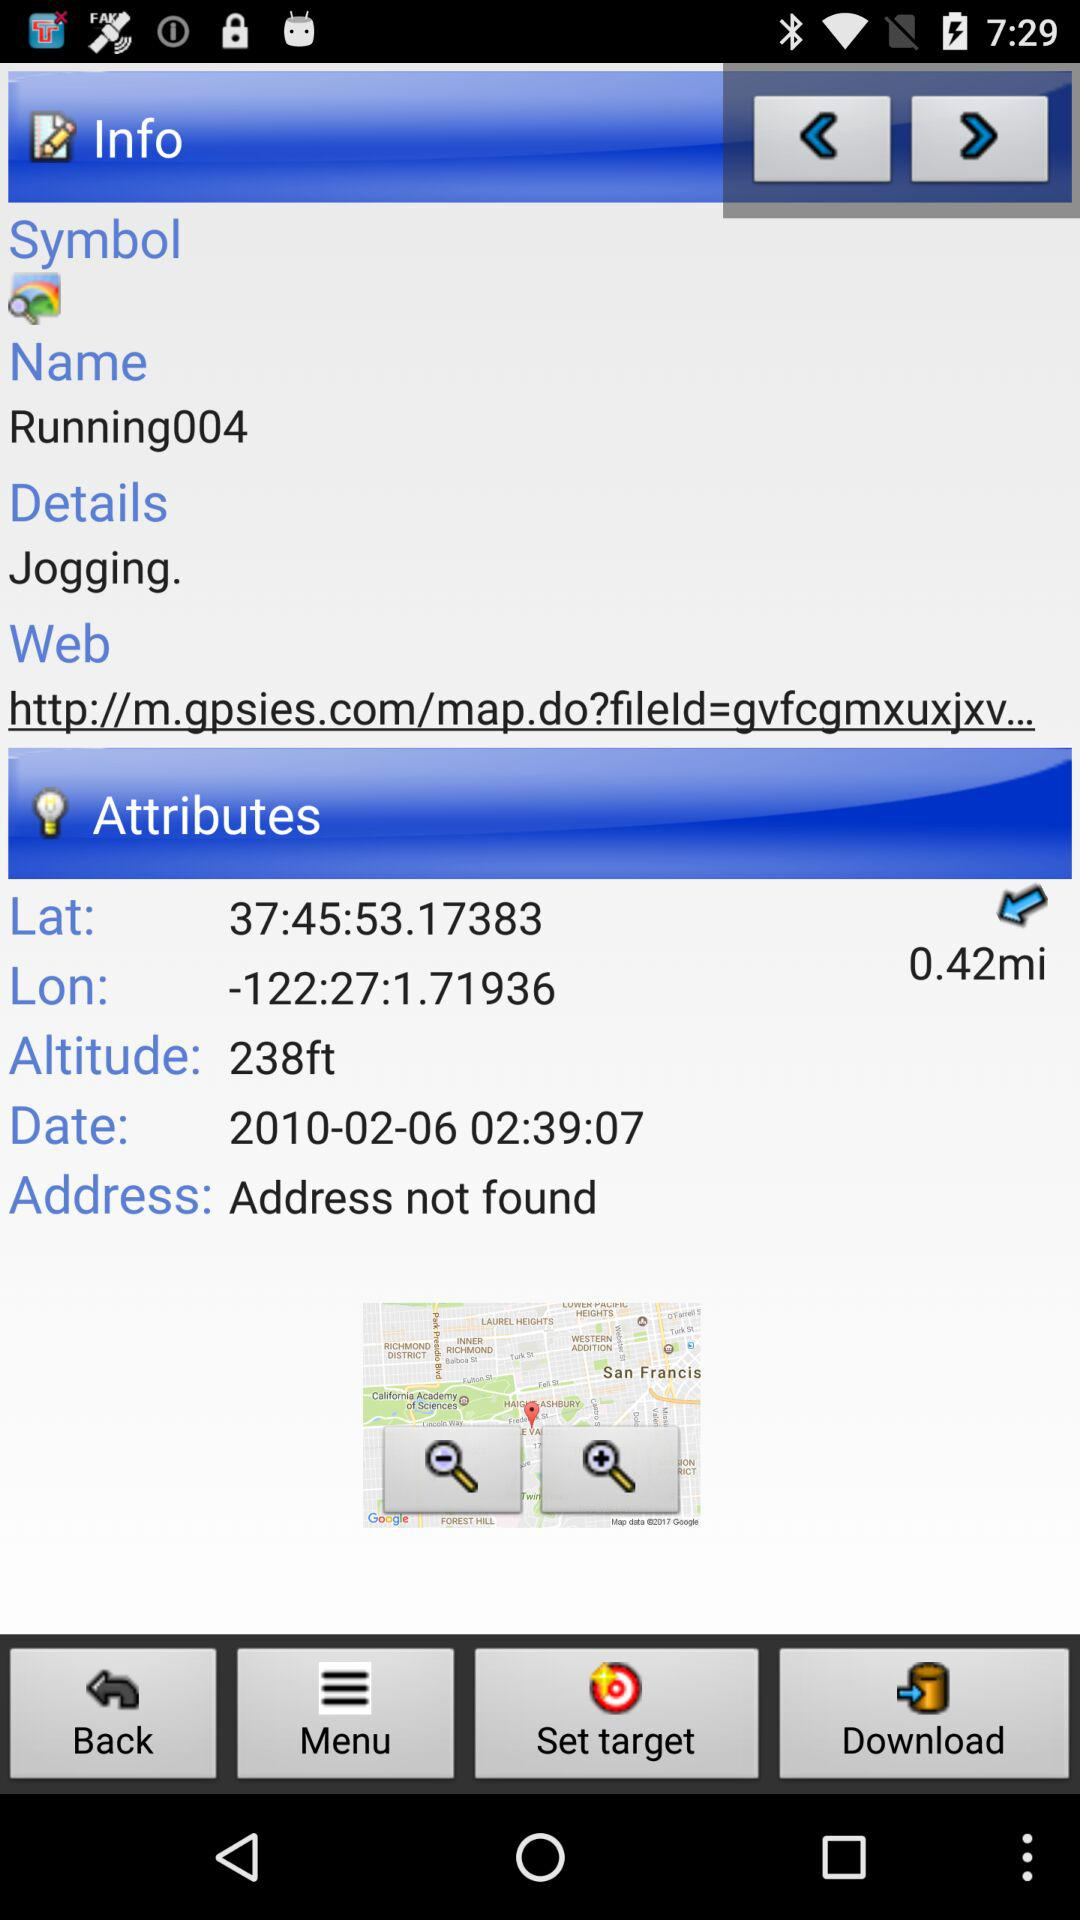What's the altitude? The altitude is 238 ft. 